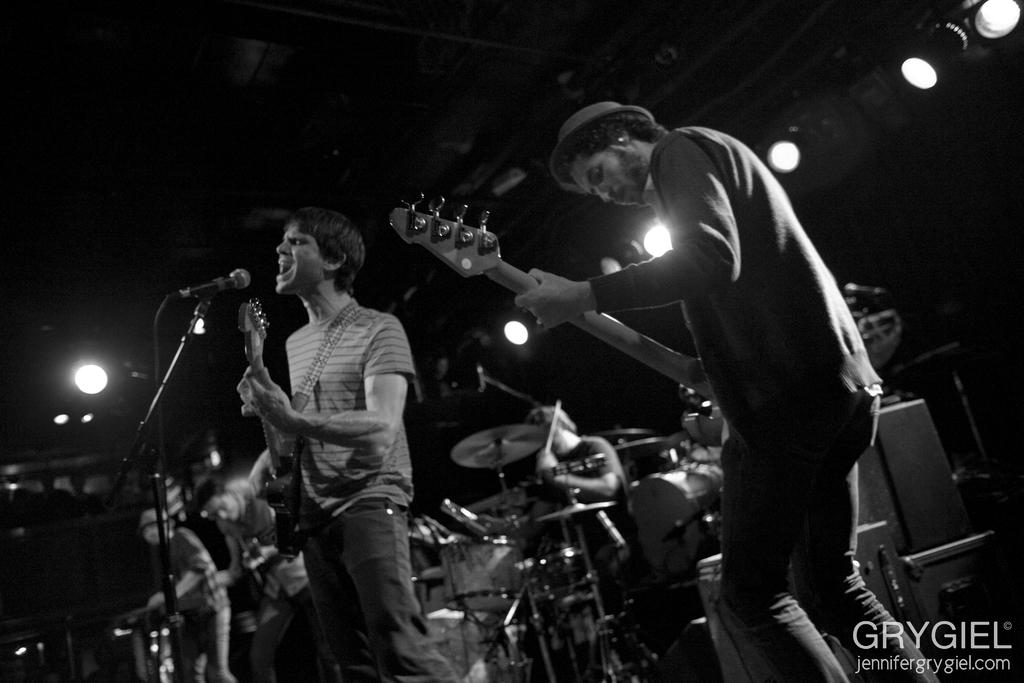What is happening on the stage in the image? There are people on the stage, and they are performing by playing musical instruments. Can you describe the performance in more detail? Yes, there is a person playing guitar and singing on a mic. What can be seen in the background of the stage? There are lights in the background. What type of fruit is being used as a prop by the person playing guitar and singing on a mic? There is no fruit present in the image; the person is playing guitar and singing on a mic without any fruit props. 